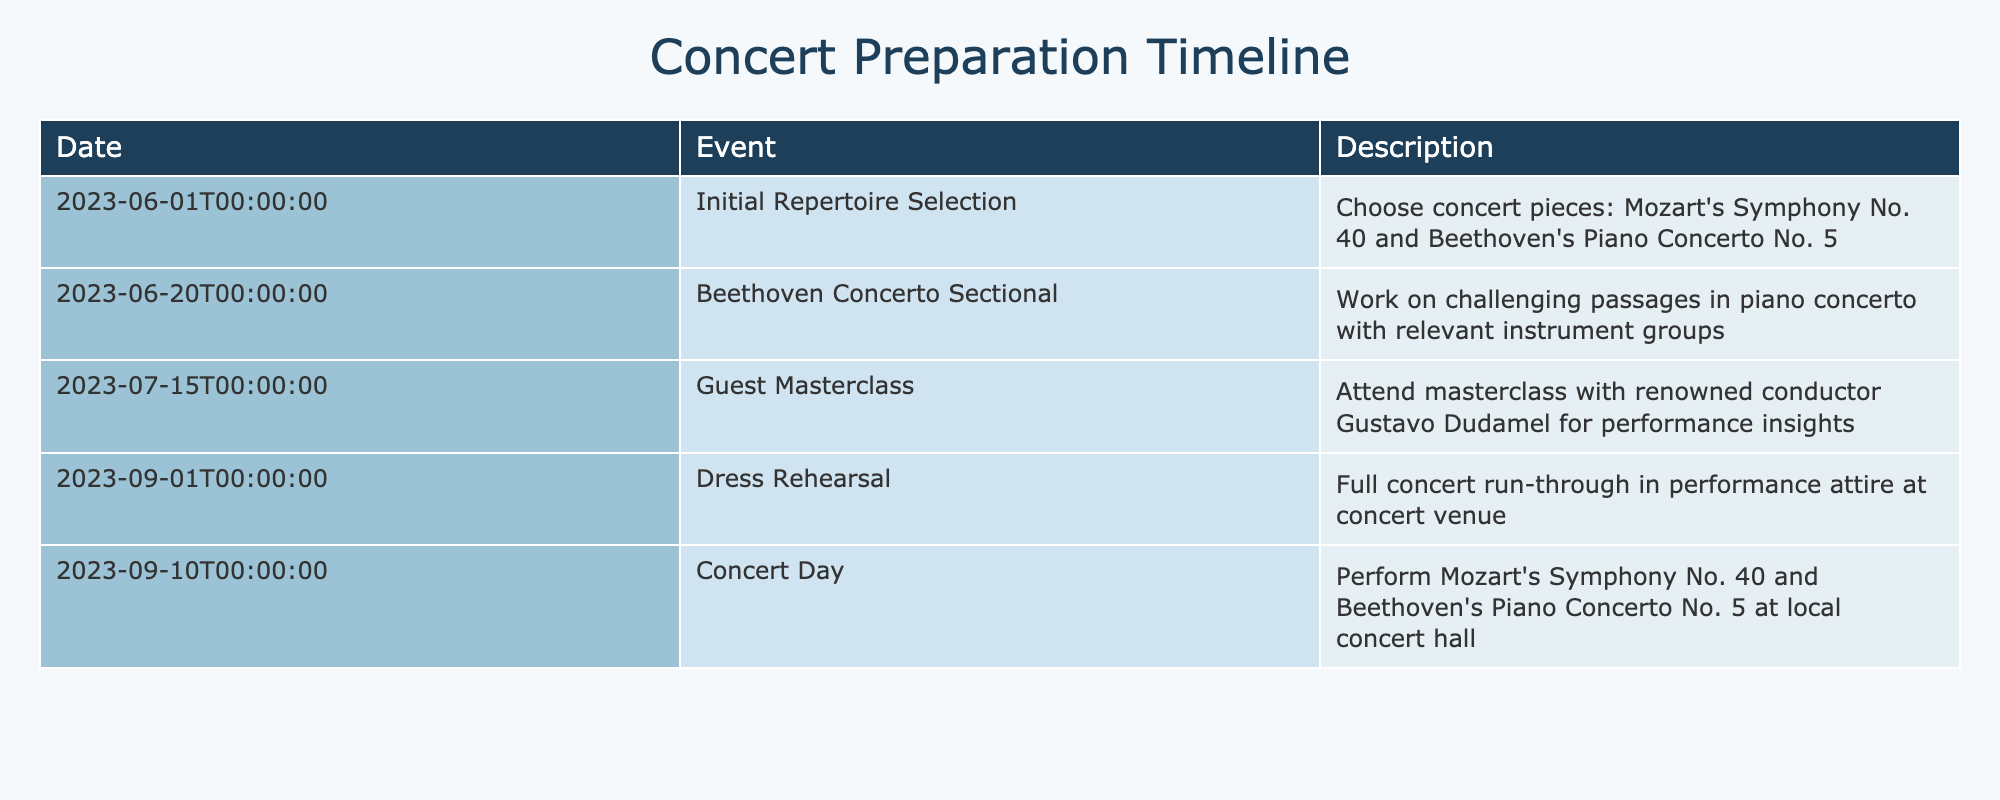What is the first event in the timeline? The first event listed in the table is on June 1, 2023, which is the "Initial Repertoire Selection." This information can be found in the first row under the Event column.
Answer: Initial Repertoire Selection How many days are between the Dress Rehearsal and Concert Day? The Dress Rehearsal is scheduled for September 1, 2023, and the Concert Day is September 10, 2023. To find the duration, we subtract September 1 from September 10, which results in 9 days.
Answer: 9 days Was there a guest masterclass before the Dress Rehearsal? The Guest Masterclass occurred on July 15, 2023, which is before the Dress Rehearsal on September 1, 2023. We can verify this by comparing the dates of both events.
Answer: Yes What is the total number of events listed in the timeline? By counting the number of rows in the table, we find that there are 5 distinct events listed in the timeline. Each event corresponds to its own row.
Answer: 5 events Does the timeline include more than one orchestral piece? The table mentions two pieces: Mozart's Symphony No. 40 and Beethoven's Piano Concerto No. 5 as part of the concert preparation. Since both are included, the answer is affirmative.
Answer: Yes What is the duration from the Initial Repertoire Selection to the Concert Day? The Initial Repertoire Selection occurred on June 1, 2023, and the Concert Day is on September 10, 2023. We find the total duration by counting the days between these two dates. This amounts to approximately 100 days.
Answer: 100 days What event directly precedes the Concert Day? The event that directly precedes the Concert Day on the timeline is the Dress Rehearsal, which occurs on September 1, 2023. We can identify this by looking at the rows before the Concert Day.
Answer: Dress Rehearsal How many weeks are there between the Guest Masterclass and the Dress Rehearsal? The Guest Masterclass occurred on July 15, 2023, and the Dress Rehearsal took place on September 1, 2023. The time between these two events is 7 weeks, as there are 7 days in a week and it’s approximately 7 weeks from mid-July to early September.
Answer: 7 weeks 